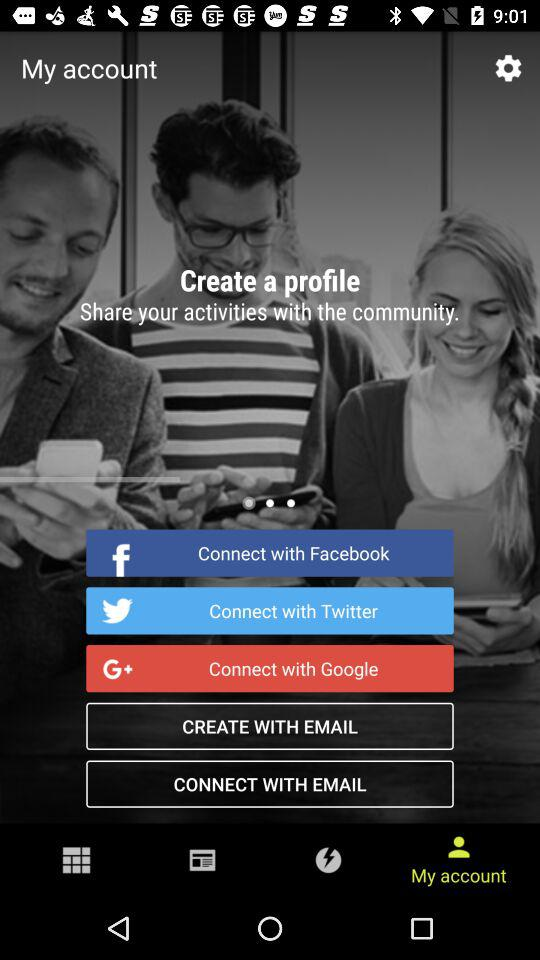What is the number of articles in "Google"? The number of articles in "Google" is 1,098. 